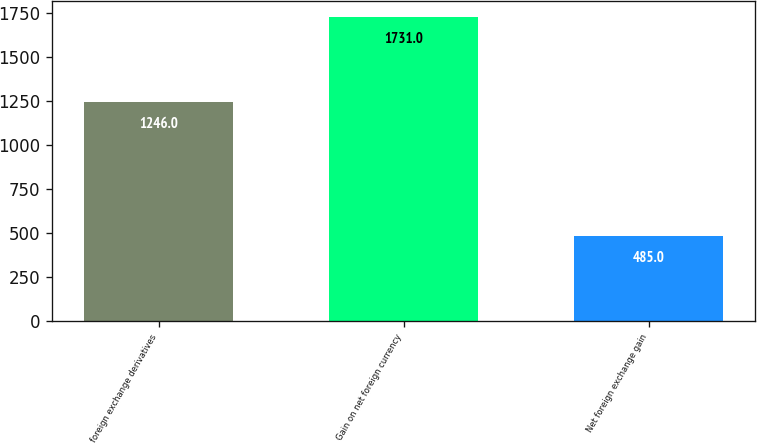Convert chart. <chart><loc_0><loc_0><loc_500><loc_500><bar_chart><fcel>foreign exchange derivatives<fcel>Gain on net foreign currency<fcel>Net foreign exchange gain<nl><fcel>1246<fcel>1731<fcel>485<nl></chart> 